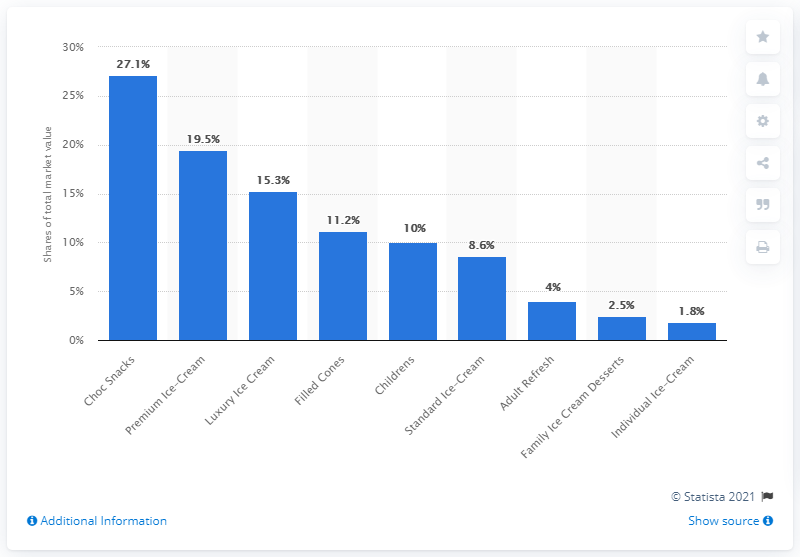Draw attention to some important aspects in this diagram. According to the data provided, chocolate snacks held 27.1% of the total market share in 2020. 